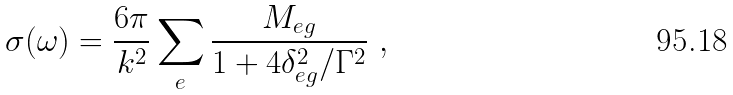<formula> <loc_0><loc_0><loc_500><loc_500>\sigma ( \omega ) = \frac { 6 \pi } { k ^ { 2 } } \sum _ { e } \frac { M _ { e g } } { 1 + 4 \delta _ { e g } ^ { 2 } / \Gamma ^ { 2 } } \ ,</formula> 